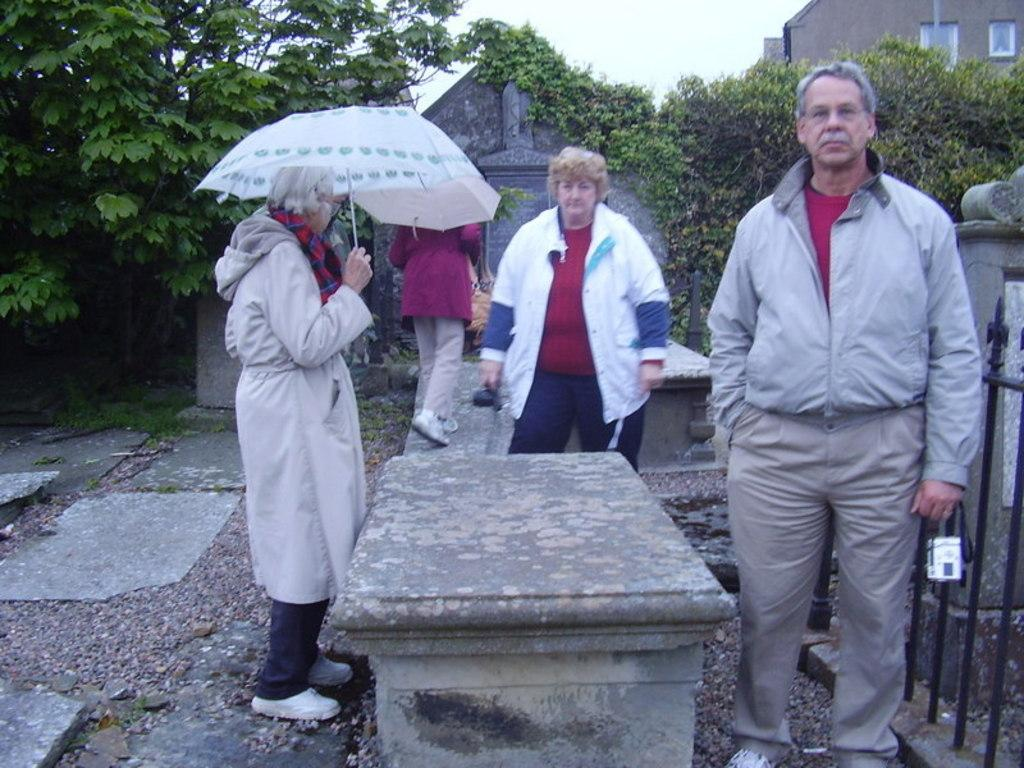How many people are present in the image? There are people standing in the image. What is one woman holding in the image? One woman is holding an umbrella. What can be seen in the background of the image? There are buildings and trees visible in the background. What type of wool is being used to make the bed in the image? There is no bed present in the image, so it is not possible to determine what type of wool might be used. 